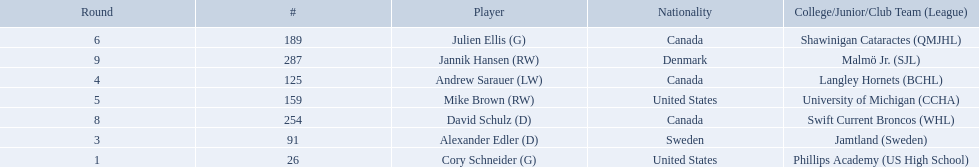Who are the players? Cory Schneider (G), Alexander Edler (D), Andrew Sarauer (LW), Mike Brown (RW), Julien Ellis (G), David Schulz (D), Jannik Hansen (RW). Of those, who is from denmark? Jannik Hansen (RW). Which players have canadian nationality? Andrew Sarauer (LW), Julien Ellis (G), David Schulz (D). Of those, which attended langley hornets? Andrew Sarauer (LW). 